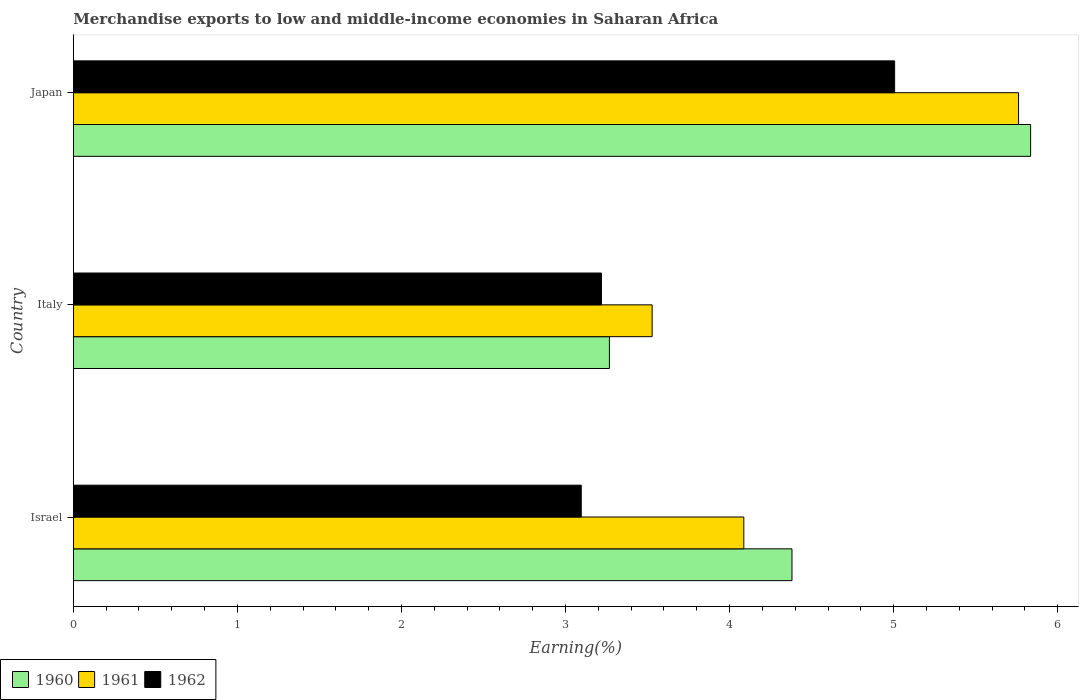How many different coloured bars are there?
Give a very brief answer. 3. Are the number of bars per tick equal to the number of legend labels?
Your answer should be very brief. Yes. Are the number of bars on each tick of the Y-axis equal?
Provide a short and direct response. Yes. How many bars are there on the 1st tick from the bottom?
Ensure brevity in your answer.  3. What is the label of the 2nd group of bars from the top?
Your response must be concise. Italy. In how many cases, is the number of bars for a given country not equal to the number of legend labels?
Offer a very short reply. 0. What is the percentage of amount earned from merchandise exports in 1960 in Italy?
Ensure brevity in your answer.  3.27. Across all countries, what is the maximum percentage of amount earned from merchandise exports in 1962?
Offer a terse response. 5.01. Across all countries, what is the minimum percentage of amount earned from merchandise exports in 1961?
Your response must be concise. 3.53. In which country was the percentage of amount earned from merchandise exports in 1960 maximum?
Provide a short and direct response. Japan. What is the total percentage of amount earned from merchandise exports in 1961 in the graph?
Ensure brevity in your answer.  13.38. What is the difference between the percentage of amount earned from merchandise exports in 1962 in Italy and that in Japan?
Keep it short and to the point. -1.79. What is the difference between the percentage of amount earned from merchandise exports in 1962 in Israel and the percentage of amount earned from merchandise exports in 1961 in Italy?
Your answer should be compact. -0.43. What is the average percentage of amount earned from merchandise exports in 1962 per country?
Give a very brief answer. 3.77. What is the difference between the percentage of amount earned from merchandise exports in 1961 and percentage of amount earned from merchandise exports in 1962 in Japan?
Your response must be concise. 0.76. What is the ratio of the percentage of amount earned from merchandise exports in 1960 in Italy to that in Japan?
Your answer should be very brief. 0.56. Is the difference between the percentage of amount earned from merchandise exports in 1961 in Italy and Japan greater than the difference between the percentage of amount earned from merchandise exports in 1962 in Italy and Japan?
Your answer should be compact. No. What is the difference between the highest and the second highest percentage of amount earned from merchandise exports in 1960?
Your answer should be compact. 1.45. What is the difference between the highest and the lowest percentage of amount earned from merchandise exports in 1962?
Keep it short and to the point. 1.91. Is the sum of the percentage of amount earned from merchandise exports in 1961 in Italy and Japan greater than the maximum percentage of amount earned from merchandise exports in 1960 across all countries?
Keep it short and to the point. Yes. What does the 1st bar from the top in Japan represents?
Your answer should be very brief. 1962. What does the 1st bar from the bottom in Italy represents?
Make the answer very short. 1960. Is it the case that in every country, the sum of the percentage of amount earned from merchandise exports in 1960 and percentage of amount earned from merchandise exports in 1961 is greater than the percentage of amount earned from merchandise exports in 1962?
Provide a short and direct response. Yes. How many bars are there?
Offer a terse response. 9. How many countries are there in the graph?
Provide a short and direct response. 3. Are the values on the major ticks of X-axis written in scientific E-notation?
Make the answer very short. No. Does the graph contain any zero values?
Offer a terse response. No. Where does the legend appear in the graph?
Ensure brevity in your answer.  Bottom left. How are the legend labels stacked?
Give a very brief answer. Horizontal. What is the title of the graph?
Give a very brief answer. Merchandise exports to low and middle-income economies in Saharan Africa. Does "2006" appear as one of the legend labels in the graph?
Keep it short and to the point. No. What is the label or title of the X-axis?
Ensure brevity in your answer.  Earning(%). What is the label or title of the Y-axis?
Offer a terse response. Country. What is the Earning(%) in 1960 in Israel?
Offer a terse response. 4.38. What is the Earning(%) in 1961 in Israel?
Make the answer very short. 4.09. What is the Earning(%) of 1962 in Israel?
Offer a terse response. 3.1. What is the Earning(%) of 1960 in Italy?
Provide a short and direct response. 3.27. What is the Earning(%) of 1961 in Italy?
Your answer should be compact. 3.53. What is the Earning(%) in 1962 in Italy?
Keep it short and to the point. 3.22. What is the Earning(%) in 1960 in Japan?
Ensure brevity in your answer.  5.83. What is the Earning(%) of 1961 in Japan?
Offer a very short reply. 5.76. What is the Earning(%) in 1962 in Japan?
Your answer should be compact. 5.01. Across all countries, what is the maximum Earning(%) in 1960?
Provide a short and direct response. 5.83. Across all countries, what is the maximum Earning(%) of 1961?
Make the answer very short. 5.76. Across all countries, what is the maximum Earning(%) of 1962?
Your answer should be compact. 5.01. Across all countries, what is the minimum Earning(%) of 1960?
Keep it short and to the point. 3.27. Across all countries, what is the minimum Earning(%) of 1961?
Provide a succinct answer. 3.53. Across all countries, what is the minimum Earning(%) in 1962?
Make the answer very short. 3.1. What is the total Earning(%) of 1960 in the graph?
Your response must be concise. 13.48. What is the total Earning(%) of 1961 in the graph?
Keep it short and to the point. 13.38. What is the total Earning(%) in 1962 in the graph?
Provide a short and direct response. 11.32. What is the difference between the Earning(%) in 1960 in Israel and that in Italy?
Your response must be concise. 1.11. What is the difference between the Earning(%) in 1961 in Israel and that in Italy?
Offer a very short reply. 0.56. What is the difference between the Earning(%) of 1962 in Israel and that in Italy?
Your answer should be compact. -0.12. What is the difference between the Earning(%) in 1960 in Israel and that in Japan?
Your response must be concise. -1.45. What is the difference between the Earning(%) in 1961 in Israel and that in Japan?
Ensure brevity in your answer.  -1.67. What is the difference between the Earning(%) of 1962 in Israel and that in Japan?
Give a very brief answer. -1.91. What is the difference between the Earning(%) in 1960 in Italy and that in Japan?
Offer a terse response. -2.57. What is the difference between the Earning(%) of 1961 in Italy and that in Japan?
Provide a short and direct response. -2.23. What is the difference between the Earning(%) of 1962 in Italy and that in Japan?
Ensure brevity in your answer.  -1.79. What is the difference between the Earning(%) in 1960 in Israel and the Earning(%) in 1961 in Italy?
Make the answer very short. 0.85. What is the difference between the Earning(%) of 1960 in Israel and the Earning(%) of 1962 in Italy?
Ensure brevity in your answer.  1.16. What is the difference between the Earning(%) of 1961 in Israel and the Earning(%) of 1962 in Italy?
Offer a terse response. 0.87. What is the difference between the Earning(%) of 1960 in Israel and the Earning(%) of 1961 in Japan?
Offer a very short reply. -1.38. What is the difference between the Earning(%) in 1960 in Israel and the Earning(%) in 1962 in Japan?
Offer a terse response. -0.63. What is the difference between the Earning(%) in 1961 in Israel and the Earning(%) in 1962 in Japan?
Ensure brevity in your answer.  -0.92. What is the difference between the Earning(%) of 1960 in Italy and the Earning(%) of 1961 in Japan?
Provide a short and direct response. -2.49. What is the difference between the Earning(%) in 1960 in Italy and the Earning(%) in 1962 in Japan?
Provide a succinct answer. -1.74. What is the difference between the Earning(%) in 1961 in Italy and the Earning(%) in 1962 in Japan?
Your answer should be compact. -1.48. What is the average Earning(%) in 1960 per country?
Ensure brevity in your answer.  4.49. What is the average Earning(%) of 1961 per country?
Provide a short and direct response. 4.46. What is the average Earning(%) of 1962 per country?
Your response must be concise. 3.77. What is the difference between the Earning(%) of 1960 and Earning(%) of 1961 in Israel?
Your answer should be compact. 0.29. What is the difference between the Earning(%) in 1960 and Earning(%) in 1962 in Israel?
Provide a succinct answer. 1.28. What is the difference between the Earning(%) in 1961 and Earning(%) in 1962 in Israel?
Provide a short and direct response. 0.99. What is the difference between the Earning(%) of 1960 and Earning(%) of 1961 in Italy?
Your answer should be very brief. -0.26. What is the difference between the Earning(%) in 1960 and Earning(%) in 1962 in Italy?
Provide a short and direct response. 0.05. What is the difference between the Earning(%) in 1961 and Earning(%) in 1962 in Italy?
Provide a succinct answer. 0.31. What is the difference between the Earning(%) of 1960 and Earning(%) of 1961 in Japan?
Offer a terse response. 0.07. What is the difference between the Earning(%) in 1960 and Earning(%) in 1962 in Japan?
Your response must be concise. 0.83. What is the difference between the Earning(%) in 1961 and Earning(%) in 1962 in Japan?
Give a very brief answer. 0.76. What is the ratio of the Earning(%) in 1960 in Israel to that in Italy?
Your response must be concise. 1.34. What is the ratio of the Earning(%) in 1961 in Israel to that in Italy?
Keep it short and to the point. 1.16. What is the ratio of the Earning(%) in 1962 in Israel to that in Italy?
Ensure brevity in your answer.  0.96. What is the ratio of the Earning(%) in 1960 in Israel to that in Japan?
Your response must be concise. 0.75. What is the ratio of the Earning(%) of 1961 in Israel to that in Japan?
Keep it short and to the point. 0.71. What is the ratio of the Earning(%) in 1962 in Israel to that in Japan?
Offer a very short reply. 0.62. What is the ratio of the Earning(%) in 1960 in Italy to that in Japan?
Give a very brief answer. 0.56. What is the ratio of the Earning(%) in 1961 in Italy to that in Japan?
Make the answer very short. 0.61. What is the ratio of the Earning(%) in 1962 in Italy to that in Japan?
Your response must be concise. 0.64. What is the difference between the highest and the second highest Earning(%) of 1960?
Your answer should be compact. 1.45. What is the difference between the highest and the second highest Earning(%) of 1961?
Your response must be concise. 1.67. What is the difference between the highest and the second highest Earning(%) in 1962?
Ensure brevity in your answer.  1.79. What is the difference between the highest and the lowest Earning(%) in 1960?
Your answer should be very brief. 2.57. What is the difference between the highest and the lowest Earning(%) in 1961?
Ensure brevity in your answer.  2.23. What is the difference between the highest and the lowest Earning(%) of 1962?
Give a very brief answer. 1.91. 